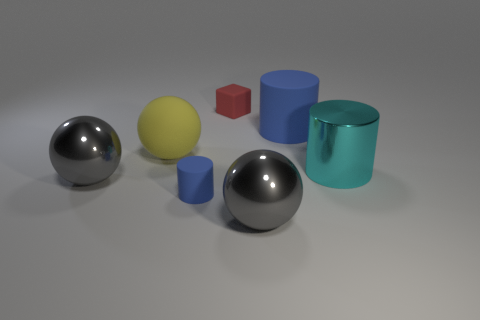Subtract 1 balls. How many balls are left? 2 Add 2 tiny red metallic cylinders. How many objects exist? 9 Subtract all cubes. How many objects are left? 6 Add 1 matte cylinders. How many matte cylinders are left? 3 Add 7 small blue objects. How many small blue objects exist? 8 Subtract 0 green balls. How many objects are left? 7 Subtract all large blue objects. Subtract all brown matte spheres. How many objects are left? 6 